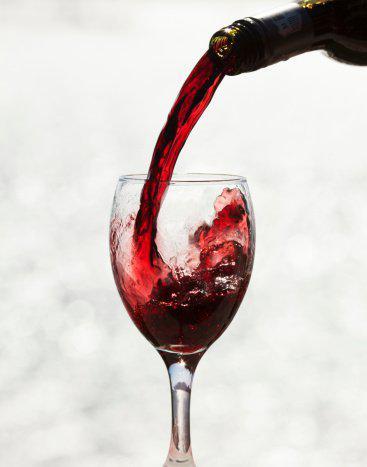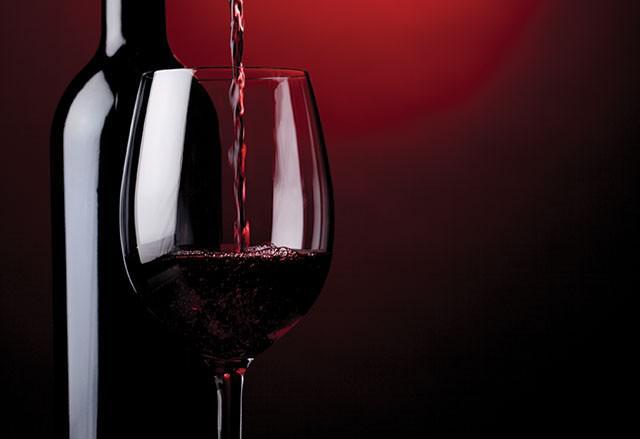The first image is the image on the left, the second image is the image on the right. Considering the images on both sides, is "There are exactly three glasses filled with red wine" valid? Answer yes or no. No. The first image is the image on the left, the second image is the image on the right. Analyze the images presented: Is the assertion "An image shows wine flowing into a glass, which stands next to an upright bottle." valid? Answer yes or no. Yes. 